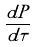Convert formula to latex. <formula><loc_0><loc_0><loc_500><loc_500>\frac { d P } { d \tau }</formula> 